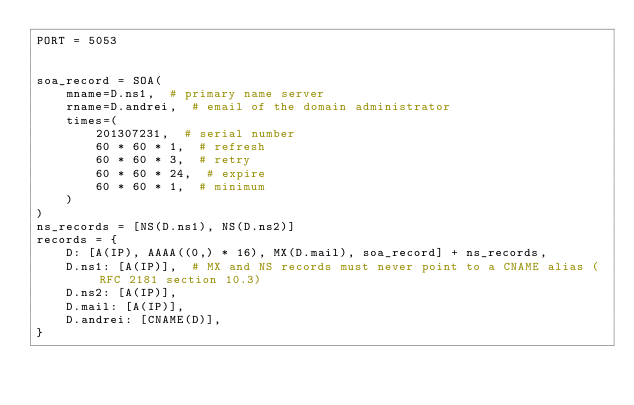<code> <loc_0><loc_0><loc_500><loc_500><_Python_>PORT = 5053


soa_record = SOA(
    mname=D.ns1,  # primary name server
    rname=D.andrei,  # email of the domain administrator
    times=(
        201307231,  # serial number
        60 * 60 * 1,  # refresh
        60 * 60 * 3,  # retry
        60 * 60 * 24,  # expire
        60 * 60 * 1,  # minimum
    )
)
ns_records = [NS(D.ns1), NS(D.ns2)]
records = {
    D: [A(IP), AAAA((0,) * 16), MX(D.mail), soa_record] + ns_records,
    D.ns1: [A(IP)],  # MX and NS records must never point to a CNAME alias (RFC 2181 section 10.3)
    D.ns2: [A(IP)],
    D.mail: [A(IP)],
    D.andrei: [CNAME(D)],
}

</code> 